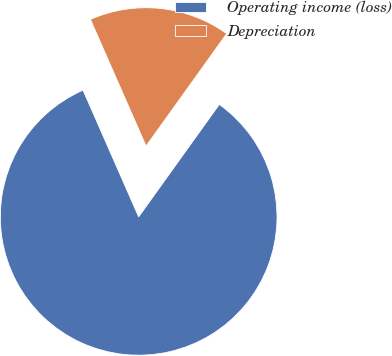Convert chart. <chart><loc_0><loc_0><loc_500><loc_500><pie_chart><fcel>Operating income (loss)<fcel>Depreciation<nl><fcel>83.51%<fcel>16.49%<nl></chart> 